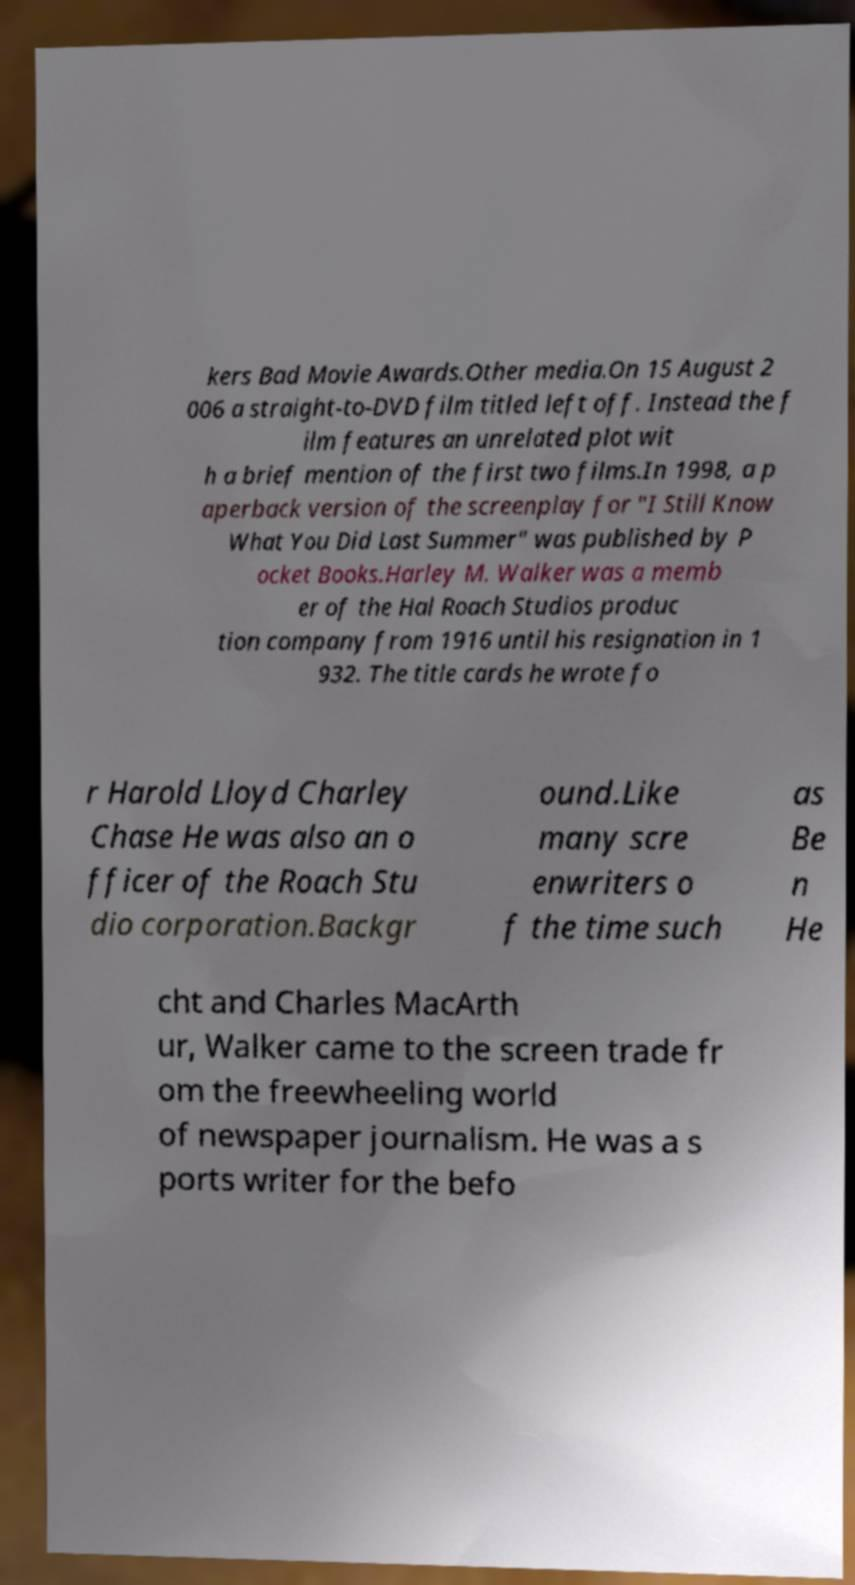Could you assist in decoding the text presented in this image and type it out clearly? kers Bad Movie Awards.Other media.On 15 August 2 006 a straight-to-DVD film titled left off. Instead the f ilm features an unrelated plot wit h a brief mention of the first two films.In 1998, a p aperback version of the screenplay for "I Still Know What You Did Last Summer" was published by P ocket Books.Harley M. Walker was a memb er of the Hal Roach Studios produc tion company from 1916 until his resignation in 1 932. The title cards he wrote fo r Harold Lloyd Charley Chase He was also an o fficer of the Roach Stu dio corporation.Backgr ound.Like many scre enwriters o f the time such as Be n He cht and Charles MacArth ur, Walker came to the screen trade fr om the freewheeling world of newspaper journalism. He was a s ports writer for the befo 